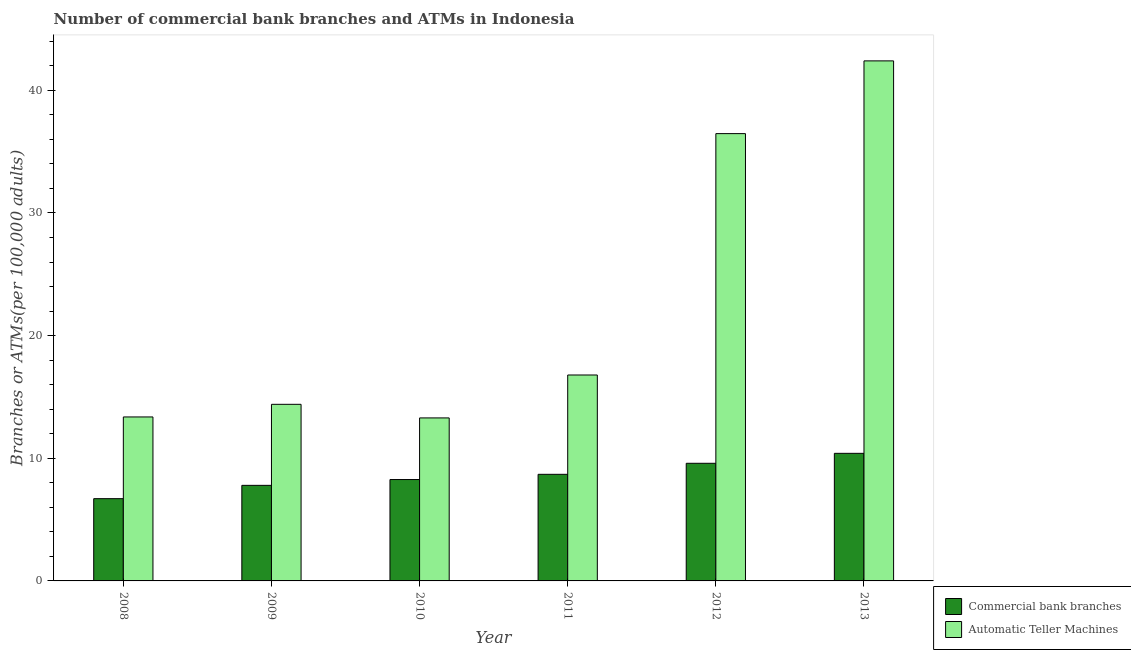How many different coloured bars are there?
Your answer should be compact. 2. Are the number of bars on each tick of the X-axis equal?
Your response must be concise. Yes. What is the number of atms in 2010?
Your answer should be very brief. 13.29. Across all years, what is the maximum number of atms?
Offer a very short reply. 42.4. Across all years, what is the minimum number of atms?
Provide a short and direct response. 13.29. What is the total number of atms in the graph?
Provide a succinct answer. 136.71. What is the difference between the number of atms in 2011 and that in 2012?
Provide a succinct answer. -19.68. What is the difference between the number of commercal bank branches in 2011 and the number of atms in 2009?
Give a very brief answer. 0.9. What is the average number of commercal bank branches per year?
Offer a terse response. 8.57. In the year 2011, what is the difference between the number of commercal bank branches and number of atms?
Provide a succinct answer. 0. What is the ratio of the number of commercal bank branches in 2009 to that in 2011?
Provide a short and direct response. 0.9. Is the number of commercal bank branches in 2010 less than that in 2011?
Offer a terse response. Yes. Is the difference between the number of atms in 2008 and 2010 greater than the difference between the number of commercal bank branches in 2008 and 2010?
Your response must be concise. No. What is the difference between the highest and the second highest number of atms?
Offer a terse response. 5.93. What is the difference between the highest and the lowest number of atms?
Your answer should be compact. 29.11. Is the sum of the number of commercal bank branches in 2008 and 2011 greater than the maximum number of atms across all years?
Offer a terse response. Yes. What does the 1st bar from the left in 2011 represents?
Keep it short and to the point. Commercial bank branches. What does the 1st bar from the right in 2010 represents?
Your answer should be very brief. Automatic Teller Machines. What is the difference between two consecutive major ticks on the Y-axis?
Make the answer very short. 10. Are the values on the major ticks of Y-axis written in scientific E-notation?
Your response must be concise. No. Does the graph contain any zero values?
Keep it short and to the point. No. How many legend labels are there?
Your answer should be compact. 2. What is the title of the graph?
Offer a very short reply. Number of commercial bank branches and ATMs in Indonesia. What is the label or title of the Y-axis?
Your answer should be very brief. Branches or ATMs(per 100,0 adults). What is the Branches or ATMs(per 100,000 adults) in Commercial bank branches in 2008?
Offer a terse response. 6.71. What is the Branches or ATMs(per 100,000 adults) of Automatic Teller Machines in 2008?
Ensure brevity in your answer.  13.37. What is the Branches or ATMs(per 100,000 adults) in Commercial bank branches in 2009?
Keep it short and to the point. 7.79. What is the Branches or ATMs(per 100,000 adults) in Automatic Teller Machines in 2009?
Provide a succinct answer. 14.4. What is the Branches or ATMs(per 100,000 adults) in Commercial bank branches in 2010?
Your answer should be compact. 8.27. What is the Branches or ATMs(per 100,000 adults) of Automatic Teller Machines in 2010?
Your answer should be very brief. 13.29. What is the Branches or ATMs(per 100,000 adults) in Commercial bank branches in 2011?
Your answer should be compact. 8.69. What is the Branches or ATMs(per 100,000 adults) of Automatic Teller Machines in 2011?
Your response must be concise. 16.79. What is the Branches or ATMs(per 100,000 adults) of Commercial bank branches in 2012?
Your answer should be very brief. 9.59. What is the Branches or ATMs(per 100,000 adults) of Automatic Teller Machines in 2012?
Your answer should be very brief. 36.47. What is the Branches or ATMs(per 100,000 adults) in Commercial bank branches in 2013?
Your response must be concise. 10.4. What is the Branches or ATMs(per 100,000 adults) of Automatic Teller Machines in 2013?
Offer a terse response. 42.4. Across all years, what is the maximum Branches or ATMs(per 100,000 adults) in Commercial bank branches?
Your response must be concise. 10.4. Across all years, what is the maximum Branches or ATMs(per 100,000 adults) of Automatic Teller Machines?
Offer a very short reply. 42.4. Across all years, what is the minimum Branches or ATMs(per 100,000 adults) in Commercial bank branches?
Give a very brief answer. 6.71. Across all years, what is the minimum Branches or ATMs(per 100,000 adults) of Automatic Teller Machines?
Your answer should be compact. 13.29. What is the total Branches or ATMs(per 100,000 adults) of Commercial bank branches in the graph?
Make the answer very short. 51.44. What is the total Branches or ATMs(per 100,000 adults) in Automatic Teller Machines in the graph?
Your response must be concise. 136.71. What is the difference between the Branches or ATMs(per 100,000 adults) in Commercial bank branches in 2008 and that in 2009?
Your answer should be compact. -1.09. What is the difference between the Branches or ATMs(per 100,000 adults) of Automatic Teller Machines in 2008 and that in 2009?
Keep it short and to the point. -1.03. What is the difference between the Branches or ATMs(per 100,000 adults) of Commercial bank branches in 2008 and that in 2010?
Offer a terse response. -1.56. What is the difference between the Branches or ATMs(per 100,000 adults) in Automatic Teller Machines in 2008 and that in 2010?
Your answer should be very brief. 0.08. What is the difference between the Branches or ATMs(per 100,000 adults) of Commercial bank branches in 2008 and that in 2011?
Ensure brevity in your answer.  -1.98. What is the difference between the Branches or ATMs(per 100,000 adults) of Automatic Teller Machines in 2008 and that in 2011?
Keep it short and to the point. -3.42. What is the difference between the Branches or ATMs(per 100,000 adults) of Commercial bank branches in 2008 and that in 2012?
Offer a very short reply. -2.88. What is the difference between the Branches or ATMs(per 100,000 adults) of Automatic Teller Machines in 2008 and that in 2012?
Your answer should be very brief. -23.1. What is the difference between the Branches or ATMs(per 100,000 adults) of Commercial bank branches in 2008 and that in 2013?
Ensure brevity in your answer.  -3.69. What is the difference between the Branches or ATMs(per 100,000 adults) in Automatic Teller Machines in 2008 and that in 2013?
Provide a short and direct response. -29.03. What is the difference between the Branches or ATMs(per 100,000 adults) of Commercial bank branches in 2009 and that in 2010?
Keep it short and to the point. -0.47. What is the difference between the Branches or ATMs(per 100,000 adults) of Automatic Teller Machines in 2009 and that in 2010?
Give a very brief answer. 1.11. What is the difference between the Branches or ATMs(per 100,000 adults) in Commercial bank branches in 2009 and that in 2011?
Your response must be concise. -0.9. What is the difference between the Branches or ATMs(per 100,000 adults) in Automatic Teller Machines in 2009 and that in 2011?
Ensure brevity in your answer.  -2.39. What is the difference between the Branches or ATMs(per 100,000 adults) in Commercial bank branches in 2009 and that in 2012?
Provide a short and direct response. -1.8. What is the difference between the Branches or ATMs(per 100,000 adults) of Automatic Teller Machines in 2009 and that in 2012?
Make the answer very short. -22.07. What is the difference between the Branches or ATMs(per 100,000 adults) in Commercial bank branches in 2009 and that in 2013?
Provide a succinct answer. -2.61. What is the difference between the Branches or ATMs(per 100,000 adults) in Automatic Teller Machines in 2009 and that in 2013?
Provide a short and direct response. -28. What is the difference between the Branches or ATMs(per 100,000 adults) of Commercial bank branches in 2010 and that in 2011?
Offer a terse response. -0.42. What is the difference between the Branches or ATMs(per 100,000 adults) in Automatic Teller Machines in 2010 and that in 2011?
Keep it short and to the point. -3.5. What is the difference between the Branches or ATMs(per 100,000 adults) in Commercial bank branches in 2010 and that in 2012?
Provide a short and direct response. -1.33. What is the difference between the Branches or ATMs(per 100,000 adults) of Automatic Teller Machines in 2010 and that in 2012?
Offer a terse response. -23.18. What is the difference between the Branches or ATMs(per 100,000 adults) of Commercial bank branches in 2010 and that in 2013?
Provide a succinct answer. -2.14. What is the difference between the Branches or ATMs(per 100,000 adults) of Automatic Teller Machines in 2010 and that in 2013?
Provide a succinct answer. -29.11. What is the difference between the Branches or ATMs(per 100,000 adults) of Commercial bank branches in 2011 and that in 2012?
Your response must be concise. -0.9. What is the difference between the Branches or ATMs(per 100,000 adults) of Automatic Teller Machines in 2011 and that in 2012?
Make the answer very short. -19.68. What is the difference between the Branches or ATMs(per 100,000 adults) in Commercial bank branches in 2011 and that in 2013?
Ensure brevity in your answer.  -1.71. What is the difference between the Branches or ATMs(per 100,000 adults) in Automatic Teller Machines in 2011 and that in 2013?
Provide a succinct answer. -25.61. What is the difference between the Branches or ATMs(per 100,000 adults) in Commercial bank branches in 2012 and that in 2013?
Make the answer very short. -0.81. What is the difference between the Branches or ATMs(per 100,000 adults) of Automatic Teller Machines in 2012 and that in 2013?
Offer a terse response. -5.93. What is the difference between the Branches or ATMs(per 100,000 adults) of Commercial bank branches in 2008 and the Branches or ATMs(per 100,000 adults) of Automatic Teller Machines in 2009?
Offer a terse response. -7.69. What is the difference between the Branches or ATMs(per 100,000 adults) of Commercial bank branches in 2008 and the Branches or ATMs(per 100,000 adults) of Automatic Teller Machines in 2010?
Your answer should be very brief. -6.58. What is the difference between the Branches or ATMs(per 100,000 adults) in Commercial bank branches in 2008 and the Branches or ATMs(per 100,000 adults) in Automatic Teller Machines in 2011?
Your answer should be compact. -10.08. What is the difference between the Branches or ATMs(per 100,000 adults) in Commercial bank branches in 2008 and the Branches or ATMs(per 100,000 adults) in Automatic Teller Machines in 2012?
Provide a short and direct response. -29.76. What is the difference between the Branches or ATMs(per 100,000 adults) of Commercial bank branches in 2008 and the Branches or ATMs(per 100,000 adults) of Automatic Teller Machines in 2013?
Your answer should be very brief. -35.69. What is the difference between the Branches or ATMs(per 100,000 adults) in Commercial bank branches in 2009 and the Branches or ATMs(per 100,000 adults) in Automatic Teller Machines in 2010?
Give a very brief answer. -5.5. What is the difference between the Branches or ATMs(per 100,000 adults) of Commercial bank branches in 2009 and the Branches or ATMs(per 100,000 adults) of Automatic Teller Machines in 2011?
Your answer should be compact. -9. What is the difference between the Branches or ATMs(per 100,000 adults) in Commercial bank branches in 2009 and the Branches or ATMs(per 100,000 adults) in Automatic Teller Machines in 2012?
Provide a short and direct response. -28.68. What is the difference between the Branches or ATMs(per 100,000 adults) in Commercial bank branches in 2009 and the Branches or ATMs(per 100,000 adults) in Automatic Teller Machines in 2013?
Your answer should be very brief. -34.61. What is the difference between the Branches or ATMs(per 100,000 adults) of Commercial bank branches in 2010 and the Branches or ATMs(per 100,000 adults) of Automatic Teller Machines in 2011?
Give a very brief answer. -8.52. What is the difference between the Branches or ATMs(per 100,000 adults) in Commercial bank branches in 2010 and the Branches or ATMs(per 100,000 adults) in Automatic Teller Machines in 2012?
Ensure brevity in your answer.  -28.2. What is the difference between the Branches or ATMs(per 100,000 adults) of Commercial bank branches in 2010 and the Branches or ATMs(per 100,000 adults) of Automatic Teller Machines in 2013?
Make the answer very short. -34.13. What is the difference between the Branches or ATMs(per 100,000 adults) in Commercial bank branches in 2011 and the Branches or ATMs(per 100,000 adults) in Automatic Teller Machines in 2012?
Your answer should be compact. -27.78. What is the difference between the Branches or ATMs(per 100,000 adults) of Commercial bank branches in 2011 and the Branches or ATMs(per 100,000 adults) of Automatic Teller Machines in 2013?
Your answer should be compact. -33.71. What is the difference between the Branches or ATMs(per 100,000 adults) in Commercial bank branches in 2012 and the Branches or ATMs(per 100,000 adults) in Automatic Teller Machines in 2013?
Offer a terse response. -32.81. What is the average Branches or ATMs(per 100,000 adults) in Commercial bank branches per year?
Make the answer very short. 8.57. What is the average Branches or ATMs(per 100,000 adults) of Automatic Teller Machines per year?
Make the answer very short. 22.78. In the year 2008, what is the difference between the Branches or ATMs(per 100,000 adults) of Commercial bank branches and Branches or ATMs(per 100,000 adults) of Automatic Teller Machines?
Provide a succinct answer. -6.66. In the year 2009, what is the difference between the Branches or ATMs(per 100,000 adults) of Commercial bank branches and Branches or ATMs(per 100,000 adults) of Automatic Teller Machines?
Provide a short and direct response. -6.61. In the year 2010, what is the difference between the Branches or ATMs(per 100,000 adults) of Commercial bank branches and Branches or ATMs(per 100,000 adults) of Automatic Teller Machines?
Your answer should be compact. -5.02. In the year 2011, what is the difference between the Branches or ATMs(per 100,000 adults) of Commercial bank branches and Branches or ATMs(per 100,000 adults) of Automatic Teller Machines?
Ensure brevity in your answer.  -8.1. In the year 2012, what is the difference between the Branches or ATMs(per 100,000 adults) in Commercial bank branches and Branches or ATMs(per 100,000 adults) in Automatic Teller Machines?
Keep it short and to the point. -26.88. In the year 2013, what is the difference between the Branches or ATMs(per 100,000 adults) of Commercial bank branches and Branches or ATMs(per 100,000 adults) of Automatic Teller Machines?
Provide a succinct answer. -32. What is the ratio of the Branches or ATMs(per 100,000 adults) of Commercial bank branches in 2008 to that in 2009?
Ensure brevity in your answer.  0.86. What is the ratio of the Branches or ATMs(per 100,000 adults) of Automatic Teller Machines in 2008 to that in 2009?
Offer a terse response. 0.93. What is the ratio of the Branches or ATMs(per 100,000 adults) of Commercial bank branches in 2008 to that in 2010?
Your answer should be compact. 0.81. What is the ratio of the Branches or ATMs(per 100,000 adults) of Automatic Teller Machines in 2008 to that in 2010?
Offer a very short reply. 1.01. What is the ratio of the Branches or ATMs(per 100,000 adults) of Commercial bank branches in 2008 to that in 2011?
Make the answer very short. 0.77. What is the ratio of the Branches or ATMs(per 100,000 adults) of Automatic Teller Machines in 2008 to that in 2011?
Your response must be concise. 0.8. What is the ratio of the Branches or ATMs(per 100,000 adults) of Commercial bank branches in 2008 to that in 2012?
Provide a succinct answer. 0.7. What is the ratio of the Branches or ATMs(per 100,000 adults) in Automatic Teller Machines in 2008 to that in 2012?
Offer a very short reply. 0.37. What is the ratio of the Branches or ATMs(per 100,000 adults) in Commercial bank branches in 2008 to that in 2013?
Provide a succinct answer. 0.64. What is the ratio of the Branches or ATMs(per 100,000 adults) of Automatic Teller Machines in 2008 to that in 2013?
Provide a short and direct response. 0.32. What is the ratio of the Branches or ATMs(per 100,000 adults) in Commercial bank branches in 2009 to that in 2010?
Keep it short and to the point. 0.94. What is the ratio of the Branches or ATMs(per 100,000 adults) of Automatic Teller Machines in 2009 to that in 2010?
Your answer should be very brief. 1.08. What is the ratio of the Branches or ATMs(per 100,000 adults) in Commercial bank branches in 2009 to that in 2011?
Keep it short and to the point. 0.9. What is the ratio of the Branches or ATMs(per 100,000 adults) in Automatic Teller Machines in 2009 to that in 2011?
Keep it short and to the point. 0.86. What is the ratio of the Branches or ATMs(per 100,000 adults) of Commercial bank branches in 2009 to that in 2012?
Your answer should be very brief. 0.81. What is the ratio of the Branches or ATMs(per 100,000 adults) of Automatic Teller Machines in 2009 to that in 2012?
Ensure brevity in your answer.  0.39. What is the ratio of the Branches or ATMs(per 100,000 adults) in Commercial bank branches in 2009 to that in 2013?
Offer a very short reply. 0.75. What is the ratio of the Branches or ATMs(per 100,000 adults) of Automatic Teller Machines in 2009 to that in 2013?
Keep it short and to the point. 0.34. What is the ratio of the Branches or ATMs(per 100,000 adults) of Commercial bank branches in 2010 to that in 2011?
Offer a very short reply. 0.95. What is the ratio of the Branches or ATMs(per 100,000 adults) in Automatic Teller Machines in 2010 to that in 2011?
Keep it short and to the point. 0.79. What is the ratio of the Branches or ATMs(per 100,000 adults) of Commercial bank branches in 2010 to that in 2012?
Offer a very short reply. 0.86. What is the ratio of the Branches or ATMs(per 100,000 adults) in Automatic Teller Machines in 2010 to that in 2012?
Keep it short and to the point. 0.36. What is the ratio of the Branches or ATMs(per 100,000 adults) of Commercial bank branches in 2010 to that in 2013?
Your answer should be very brief. 0.79. What is the ratio of the Branches or ATMs(per 100,000 adults) in Automatic Teller Machines in 2010 to that in 2013?
Offer a terse response. 0.31. What is the ratio of the Branches or ATMs(per 100,000 adults) in Commercial bank branches in 2011 to that in 2012?
Provide a short and direct response. 0.91. What is the ratio of the Branches or ATMs(per 100,000 adults) in Automatic Teller Machines in 2011 to that in 2012?
Give a very brief answer. 0.46. What is the ratio of the Branches or ATMs(per 100,000 adults) in Commercial bank branches in 2011 to that in 2013?
Offer a very short reply. 0.84. What is the ratio of the Branches or ATMs(per 100,000 adults) in Automatic Teller Machines in 2011 to that in 2013?
Your answer should be compact. 0.4. What is the ratio of the Branches or ATMs(per 100,000 adults) in Commercial bank branches in 2012 to that in 2013?
Ensure brevity in your answer.  0.92. What is the ratio of the Branches or ATMs(per 100,000 adults) of Automatic Teller Machines in 2012 to that in 2013?
Make the answer very short. 0.86. What is the difference between the highest and the second highest Branches or ATMs(per 100,000 adults) in Commercial bank branches?
Offer a very short reply. 0.81. What is the difference between the highest and the second highest Branches or ATMs(per 100,000 adults) in Automatic Teller Machines?
Provide a short and direct response. 5.93. What is the difference between the highest and the lowest Branches or ATMs(per 100,000 adults) in Commercial bank branches?
Provide a succinct answer. 3.69. What is the difference between the highest and the lowest Branches or ATMs(per 100,000 adults) of Automatic Teller Machines?
Your answer should be compact. 29.11. 